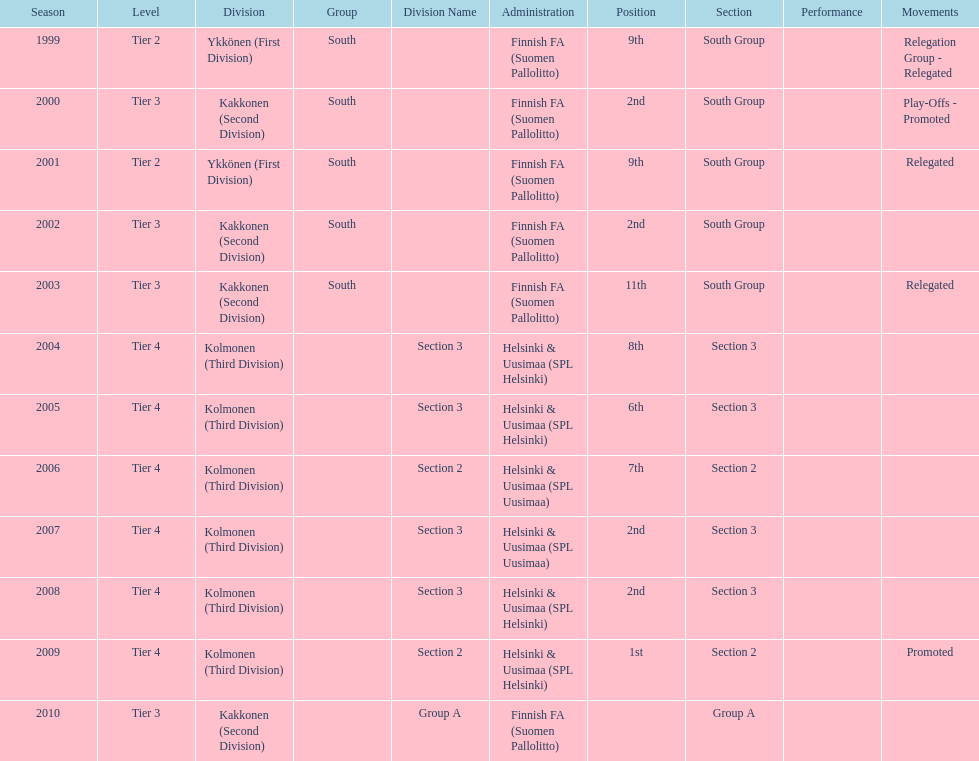When was the last year they placed 2nd? 2008. 